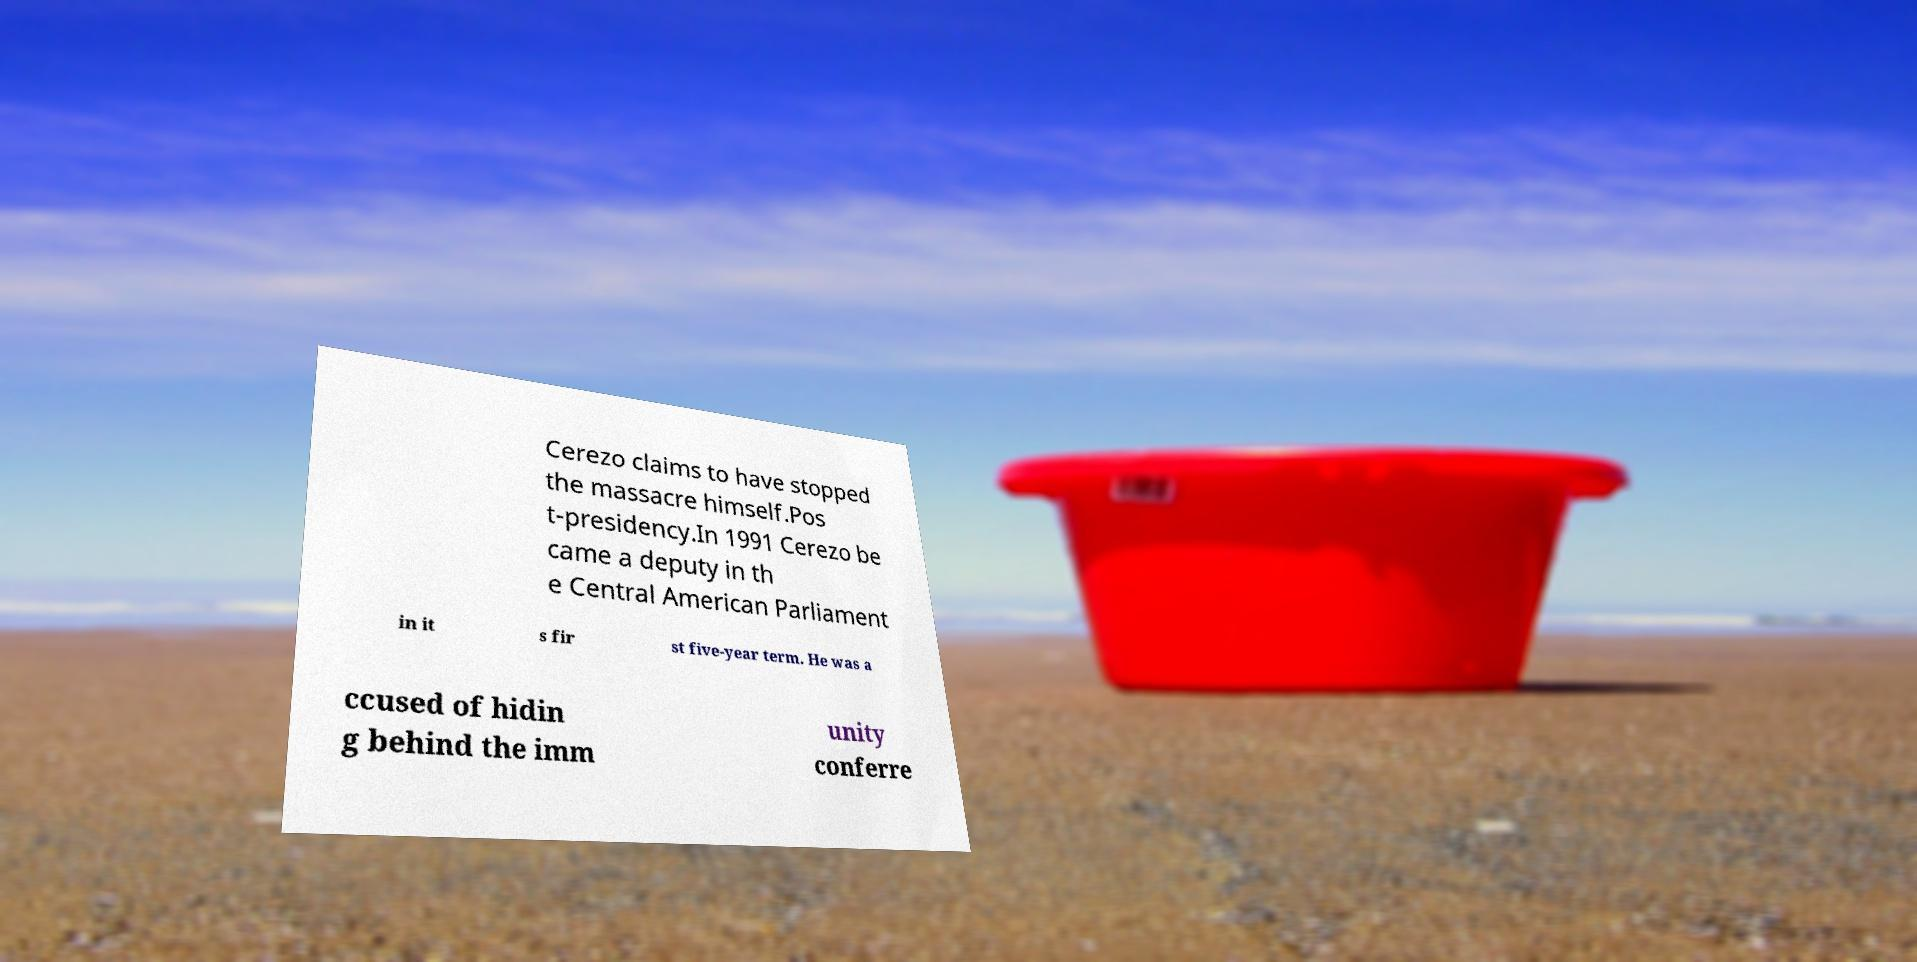Please identify and transcribe the text found in this image. Cerezo claims to have stopped the massacre himself.Pos t-presidency.In 1991 Cerezo be came a deputy in th e Central American Parliament in it s fir st five-year term. He was a ccused of hidin g behind the imm unity conferre 